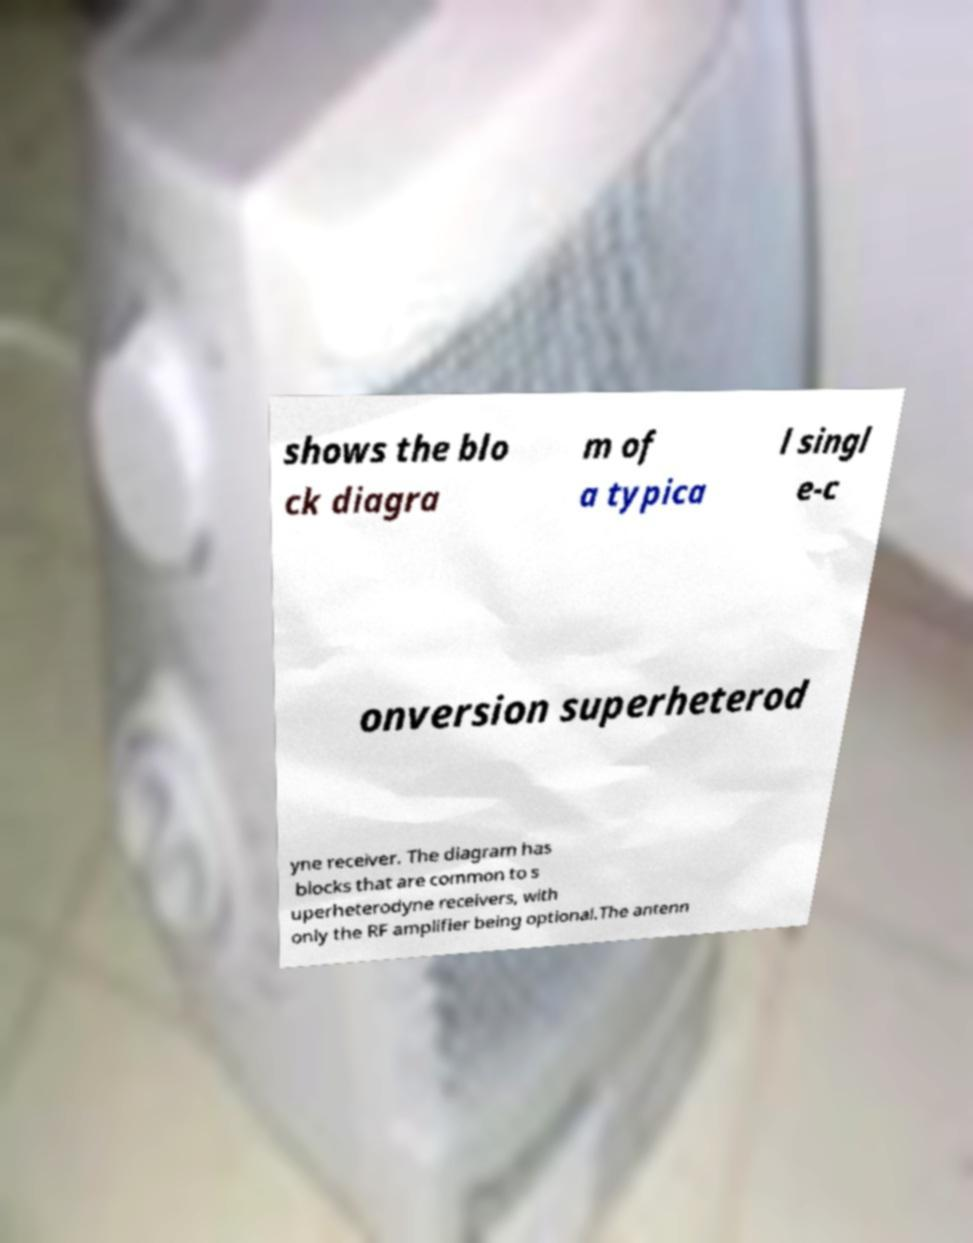Could you assist in decoding the text presented in this image and type it out clearly? shows the blo ck diagra m of a typica l singl e-c onversion superheterod yne receiver. The diagram has blocks that are common to s uperheterodyne receivers, with only the RF amplifier being optional.The antenn 